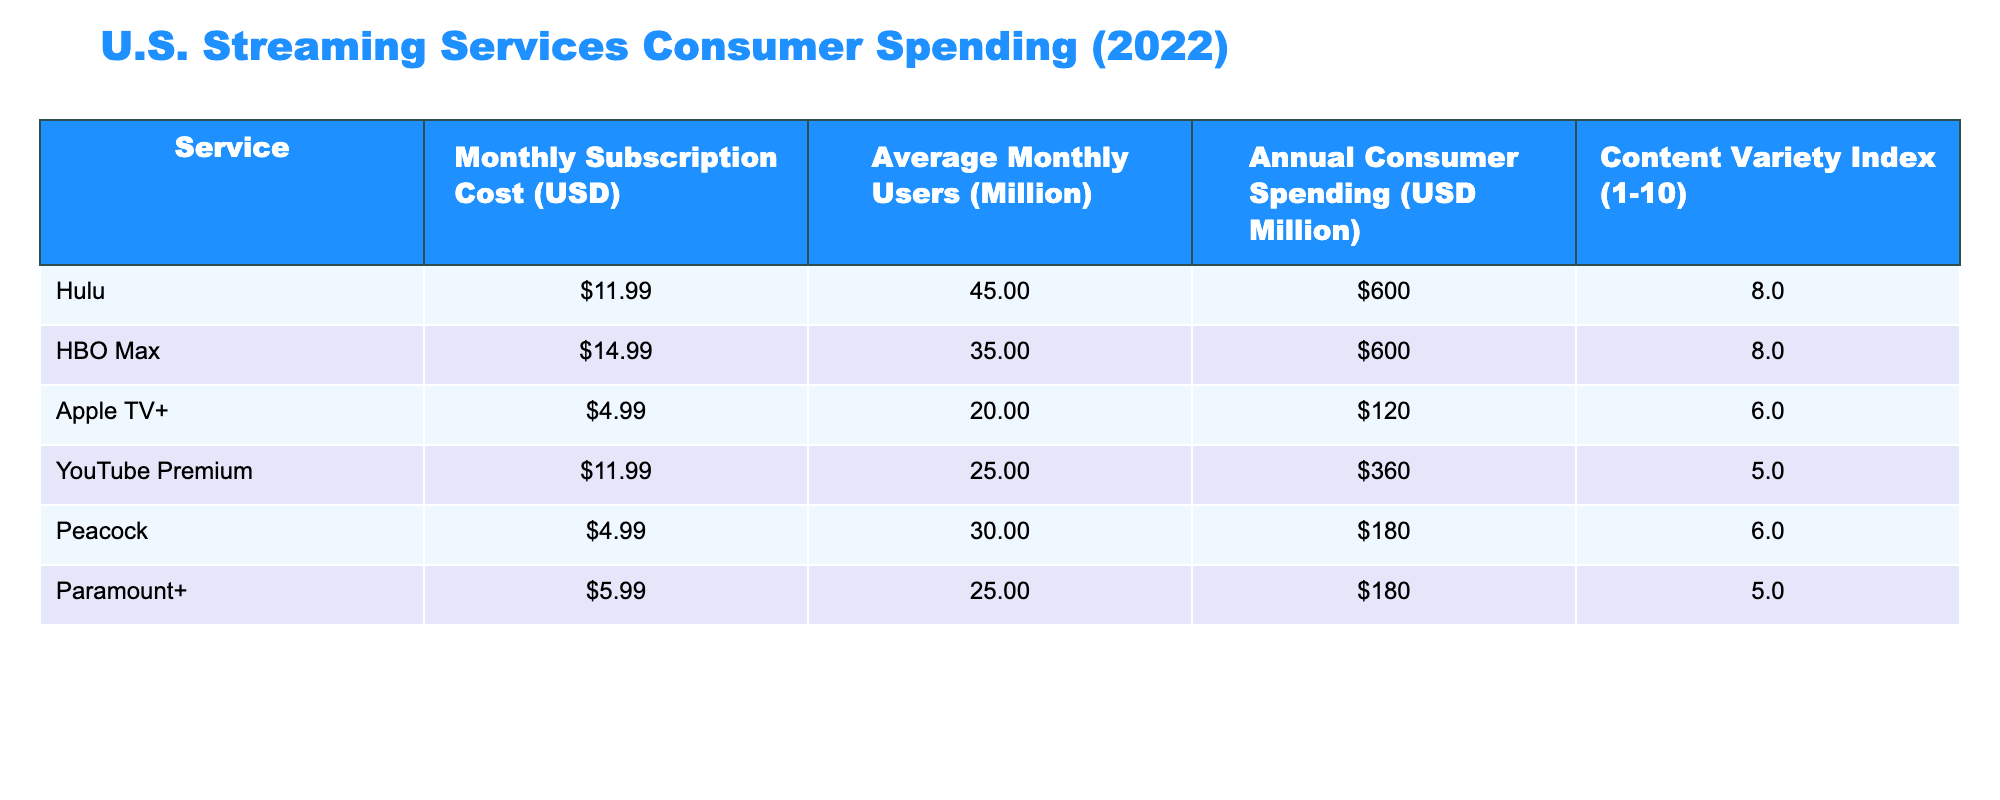What is the monthly subscription cost of Hulu? According to the table, Hulu has a monthly subscription cost listed as 11.99.
Answer: 11.99 What is the Annual Consumer Spending for HBO Max? The table lists HBO Max's Annual Consumer Spending as 600 million dollars.
Answer: 600 million dollars Which streaming service has the highest Monthly Subscription Cost? By looking at the table, HBO Max has the highest monthly subscription cost at 14.99.
Answer: HBO Max What is the total Average Monthly Users across all services? To find the total Average Monthly Users, add the Average Monthly Users for all services: 45 + 35 + 20 + 25 + 30 + 25 = 180 million.
Answer: 180 million Is the Content Variety Index of YouTube Premium greater than 5? The table shows that the Content Variety Index for YouTube Premium is 5, which means it is not greater than 5.
Answer: No Which streaming service has the lowest annual consumer spending? Compare the Annual Consumer Spending; Apple TV+ and Paramount+ both have the lowest spending at 180 million dollars.
Answer: Apple TV+ and Paramount+ What is the average Monthly Subscription Cost of streaming services in the table? To find the average Monthly Subscription Cost, sum all costs: 11.99 + 14.99 + 4.99 + 11.99 + 4.99 + 5.99 = 54.94; then divide by the number of services (6): 54.94 / 6 = approximately 9.16.
Answer: Approximately 9.16 Which service has the highest Content Variety Index, and what is its value? Looking at the Content Variety Index column, both Hulu and HBO Max have the highest value of 8.
Answer: Hulu and HBO Max, value: 8 Is the Average Monthly Users of Peacock greater than 25 million? The table indicates that Peacock has 30 million Average Monthly Users, which is greater than 25 million.
Answer: Yes 